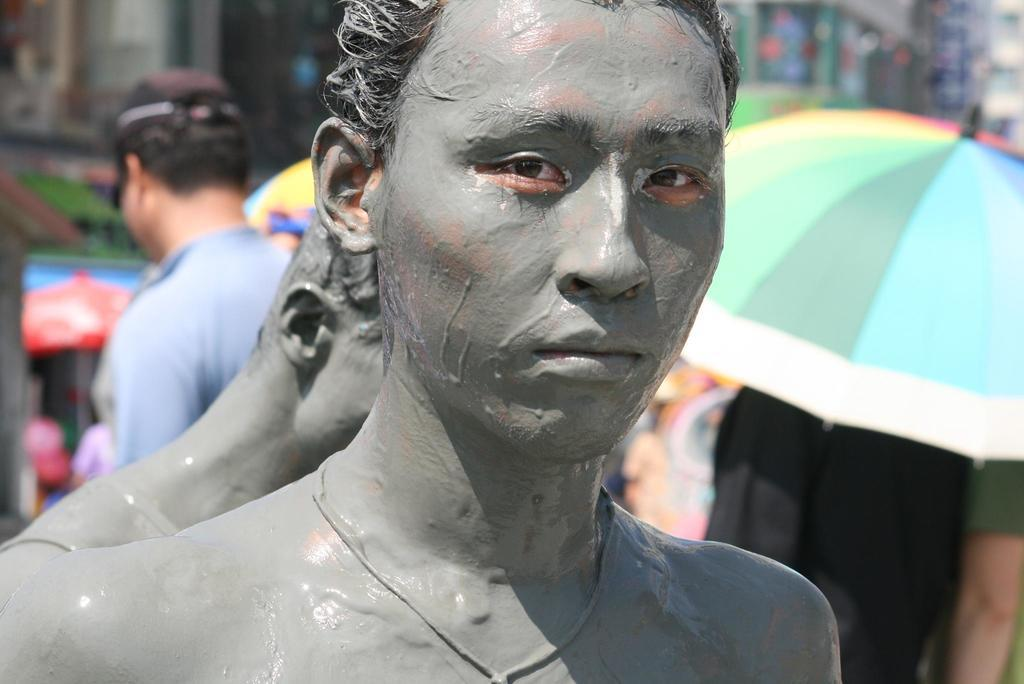How many people are in the image? There are two persons in the image. What are the persons standing near? The persons are standing near umbrellas. Can you describe the blurred image at the top of the image? Unfortunately, the image at the top of the image is blurred, so it is difficult to describe its contents. What type of polish is being applied to the neck of the person in the image? There is no indication in the image that any polish is being applied to anyone's neck. 